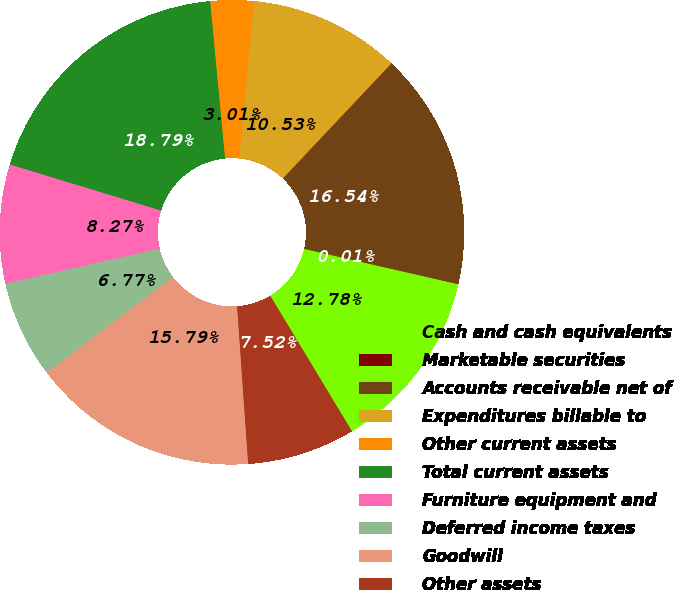Convert chart. <chart><loc_0><loc_0><loc_500><loc_500><pie_chart><fcel>Cash and cash equivalents<fcel>Marketable securities<fcel>Accounts receivable net of<fcel>Expenditures billable to<fcel>Other current assets<fcel>Total current assets<fcel>Furniture equipment and<fcel>Deferred income taxes<fcel>Goodwill<fcel>Other assets<nl><fcel>12.78%<fcel>0.01%<fcel>16.54%<fcel>10.53%<fcel>3.01%<fcel>18.79%<fcel>8.27%<fcel>6.77%<fcel>15.79%<fcel>7.52%<nl></chart> 